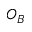<formula> <loc_0><loc_0><loc_500><loc_500>O _ { B }</formula> 